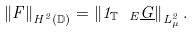<formula> <loc_0><loc_0><loc_500><loc_500>\left \| F \right \| _ { H ^ { 2 } ( { \mathbb { D } } ) } = \left \| 1 _ { { \mathbb { T } } \ E } \underline { G } \right \| _ { L _ { \mu } ^ { 2 } } .</formula> 